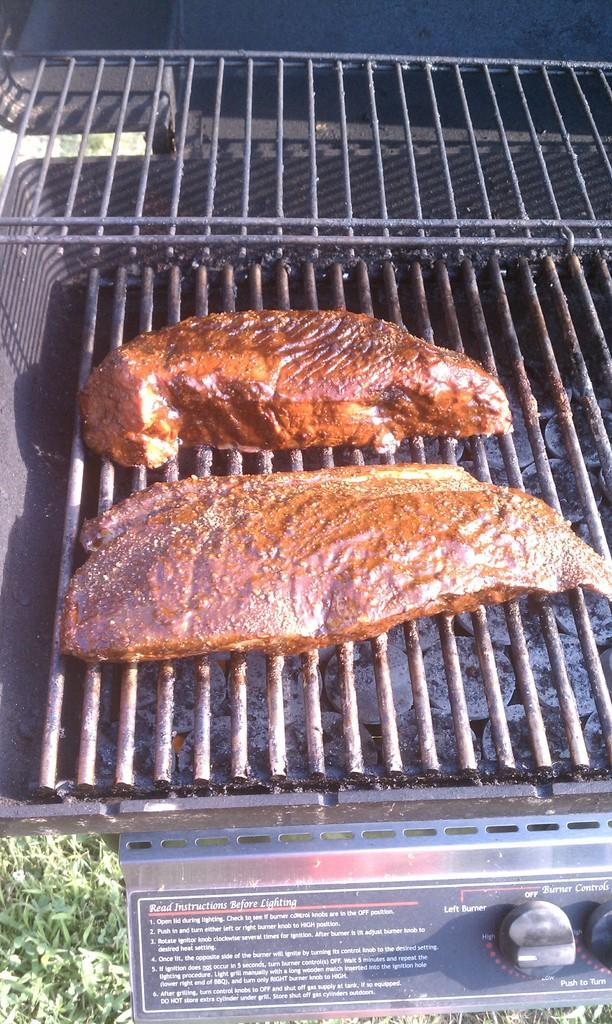<image>
Summarize the visual content of the image. two pieces of meat on a grill with words Read Instructions Before Lighting 